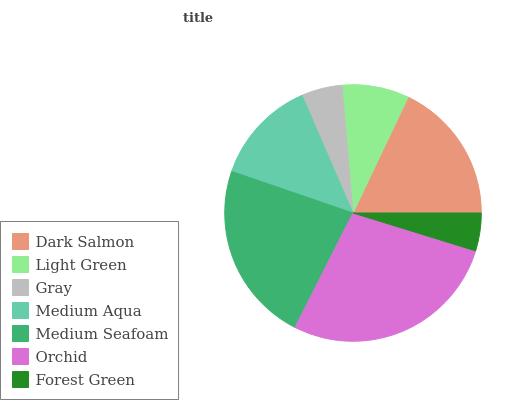Is Forest Green the minimum?
Answer yes or no. Yes. Is Orchid the maximum?
Answer yes or no. Yes. Is Light Green the minimum?
Answer yes or no. No. Is Light Green the maximum?
Answer yes or no. No. Is Dark Salmon greater than Light Green?
Answer yes or no. Yes. Is Light Green less than Dark Salmon?
Answer yes or no. Yes. Is Light Green greater than Dark Salmon?
Answer yes or no. No. Is Dark Salmon less than Light Green?
Answer yes or no. No. Is Medium Aqua the high median?
Answer yes or no. Yes. Is Medium Aqua the low median?
Answer yes or no. Yes. Is Gray the high median?
Answer yes or no. No. Is Dark Salmon the low median?
Answer yes or no. No. 